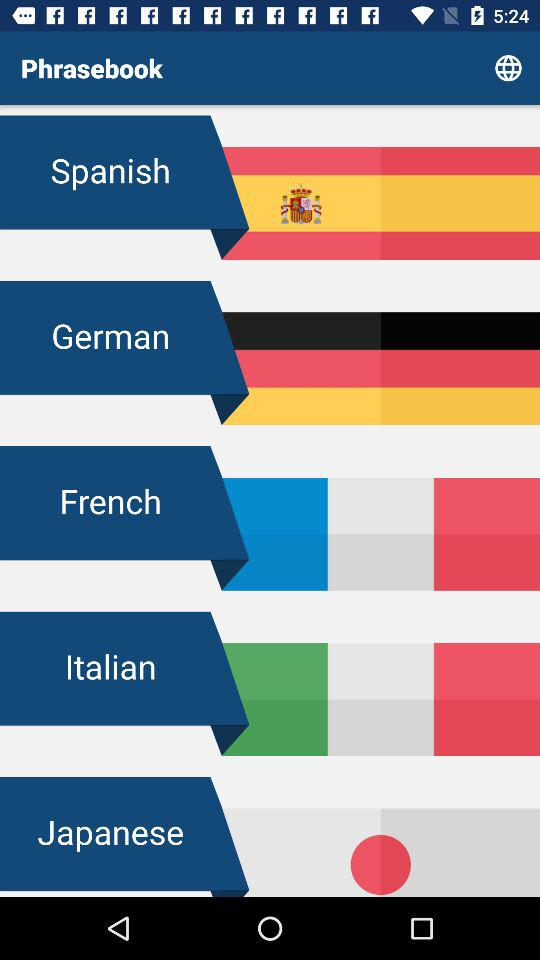What is the name of the application? The application name is "Phrasebook". 